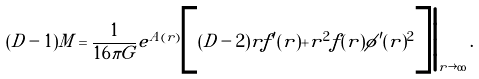Convert formula to latex. <formula><loc_0><loc_0><loc_500><loc_500>( D - 1 ) M = \frac { 1 } { 1 6 \pi G } e ^ { A ( r ) } \Big [ ( D - 2 ) r f ^ { \prime } ( r ) + r ^ { 2 } f ( r ) \phi ^ { \prime } ( r ) ^ { 2 } \Big ] \Big | _ { r \rightarrow \infty } \, .</formula> 